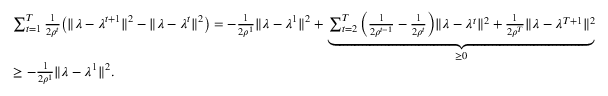Convert formula to latex. <formula><loc_0><loc_0><loc_500><loc_500>\begin{array} { r l } & { \sum _ { t = 1 } ^ { T } \frac { 1 } { 2 \rho ^ { t } } \left ( \| \lambda - \lambda ^ { t + 1 } \| ^ { 2 } - \| \lambda - \lambda ^ { t } \| ^ { 2 } \right ) = - \frac { 1 } { 2 \rho ^ { 1 } } \| \lambda - \lambda ^ { 1 } \| ^ { 2 } + \underbrace { \sum _ { t = 2 } ^ { T } \left ( \frac { 1 } { 2 \rho ^ { t - 1 } } - \frac { 1 } { 2 \rho ^ { t } } \right ) \| \lambda - \lambda ^ { t } \| ^ { 2 } + \frac { 1 } { 2 \rho ^ { T } } \| \lambda - \lambda ^ { T + 1 } \| ^ { 2 } } _ { \geq 0 } } \\ & { \geq - \frac { 1 } { 2 \rho ^ { 1 } } \| \lambda - \lambda ^ { 1 } \| ^ { 2 } . } \end{array}</formula> 